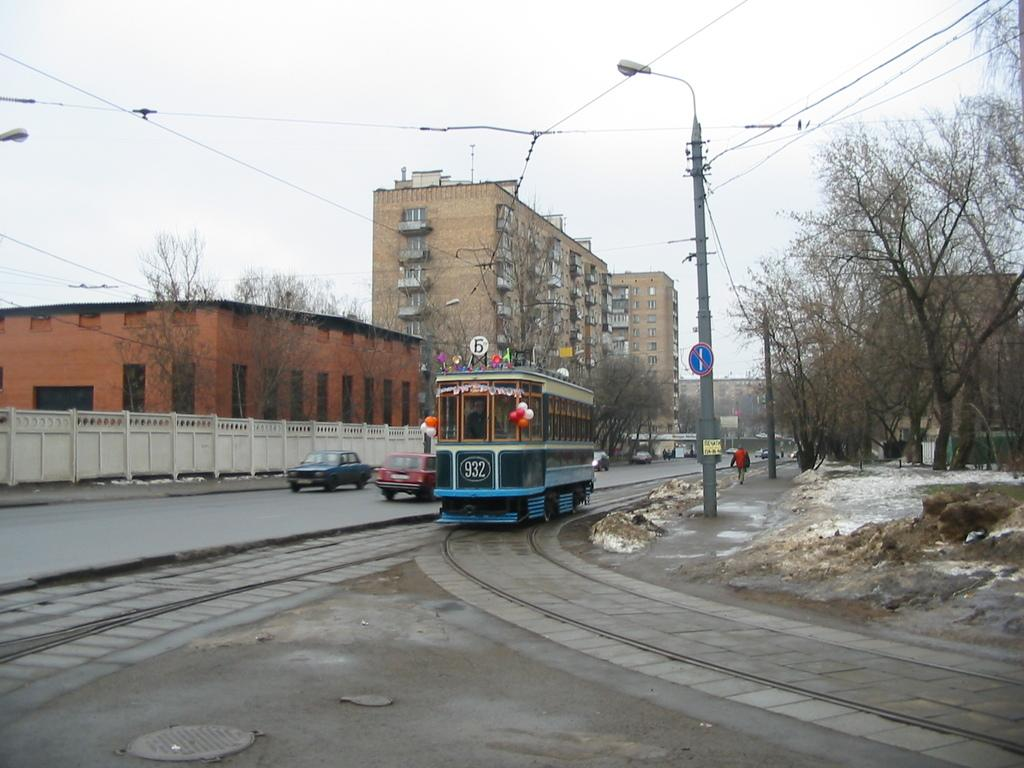<image>
Provide a brief description of the given image. An in-service cable car is labeled with the number 932. 